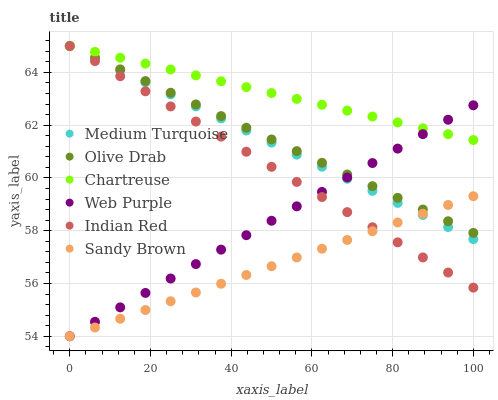Does Sandy Brown have the minimum area under the curve?
Answer yes or no. Yes. Does Chartreuse have the maximum area under the curve?
Answer yes or no. Yes. Does Web Purple have the minimum area under the curve?
Answer yes or no. No. Does Web Purple have the maximum area under the curve?
Answer yes or no. No. Is Web Purple the smoothest?
Answer yes or no. Yes. Is Chartreuse the roughest?
Answer yes or no. Yes. Is Chartreuse the smoothest?
Answer yes or no. No. Is Web Purple the roughest?
Answer yes or no. No. Does Web Purple have the lowest value?
Answer yes or no. Yes. Does Chartreuse have the lowest value?
Answer yes or no. No. Does Olive Drab have the highest value?
Answer yes or no. Yes. Does Web Purple have the highest value?
Answer yes or no. No. Is Sandy Brown less than Chartreuse?
Answer yes or no. Yes. Is Chartreuse greater than Sandy Brown?
Answer yes or no. Yes. Does Indian Red intersect Web Purple?
Answer yes or no. Yes. Is Indian Red less than Web Purple?
Answer yes or no. No. Is Indian Red greater than Web Purple?
Answer yes or no. No. Does Sandy Brown intersect Chartreuse?
Answer yes or no. No. 